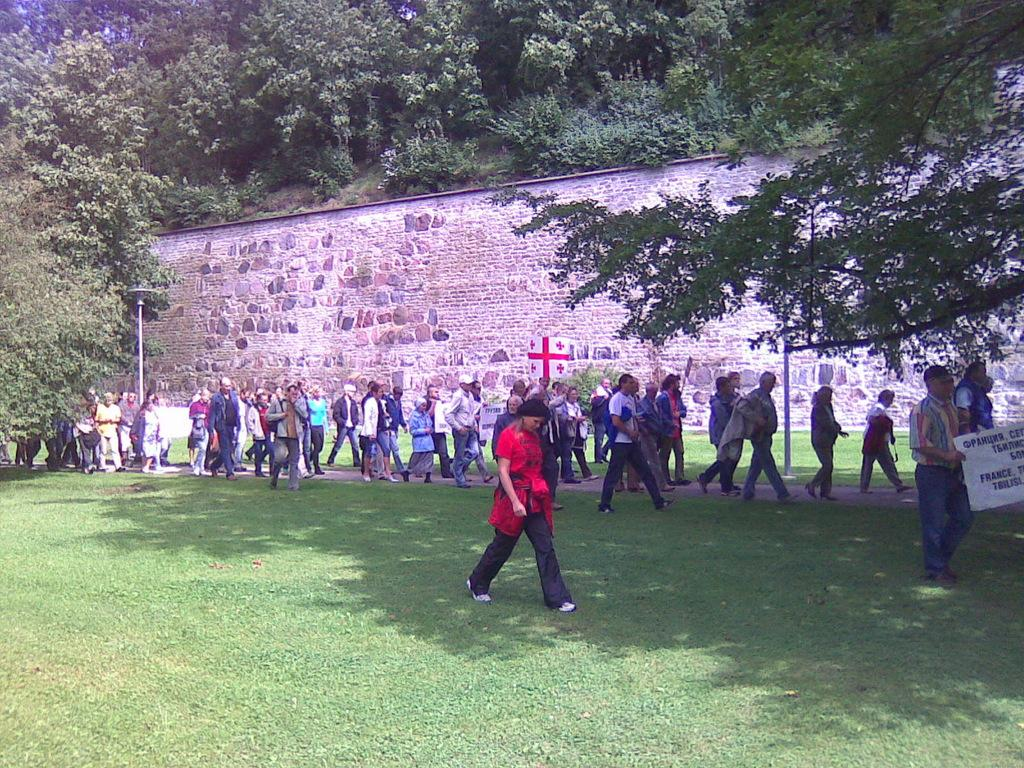What are the people in the image doing? There is a group of people walking in the image. What can be seen on the white-colored board in the image? The facts provided do not mention any details about the white-colored board, so we cannot determine what is on it. What is visible in the background of the image? There is a wall and trees with green color in the background of the image. What type of care can be seen being provided to the pan in the image? There is no pan present in the image, so no care can be provided to it. 